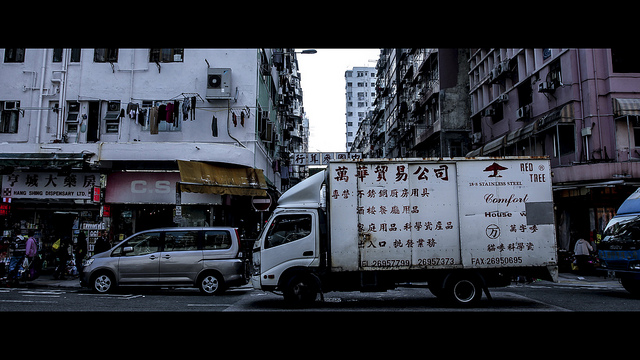Describe the atmosphere of the location pictured. The image portrays a bustling urban scene typical of a close-knit neighborhood. The overcast sky suggests it might be early morning or late afternoon, potentially during a less busy time of the day. Storefronts are open and appear active, while the architecture indicates an area that is likely densely populated. The presence of commercial activities, along with the truck, which possibly plays a role in this economic setting, highlights the dynamic nature of everyday life in this locale. Can you make any cultural inferences from the signs on the buildings and the truck? The characters on the signs and the truck suggest that the image is set in a region where Chinese is the predominant language, likely a city's commercial district. The scripts indicate a vibrant local economy with businesses that cater to both everyday needs and specialized services. These commercial signs are a visual testament to the cultural and economic activity in this urban landscape. 